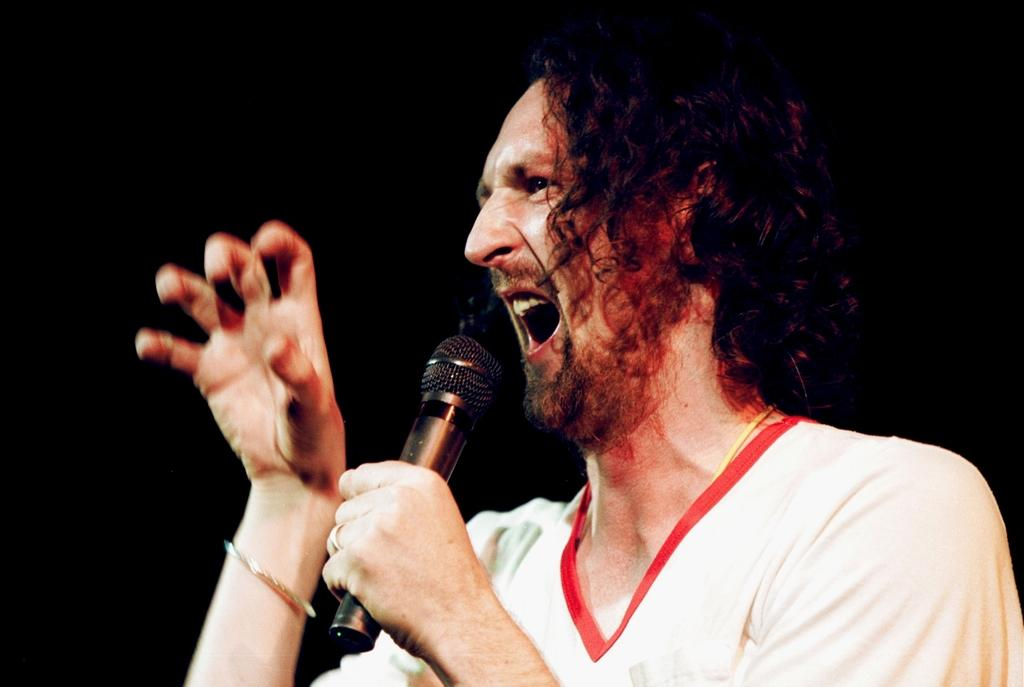What is the main subject in the foreground of the image? There is a person in the foreground of the image. What is the person holding in the image? The person is holding a microphone. What activity does the person appear to be engaged in? The person appears to be singing. What is the color of the background in the image? The background of the image is black. Can you see any trays being carried by the person in the image? There are no trays visible in the image; the person is holding a microphone and appears to be singing. What type of zephyr can be seen blowing in the background of the image? There is no zephyr present in the image; the background is black. 